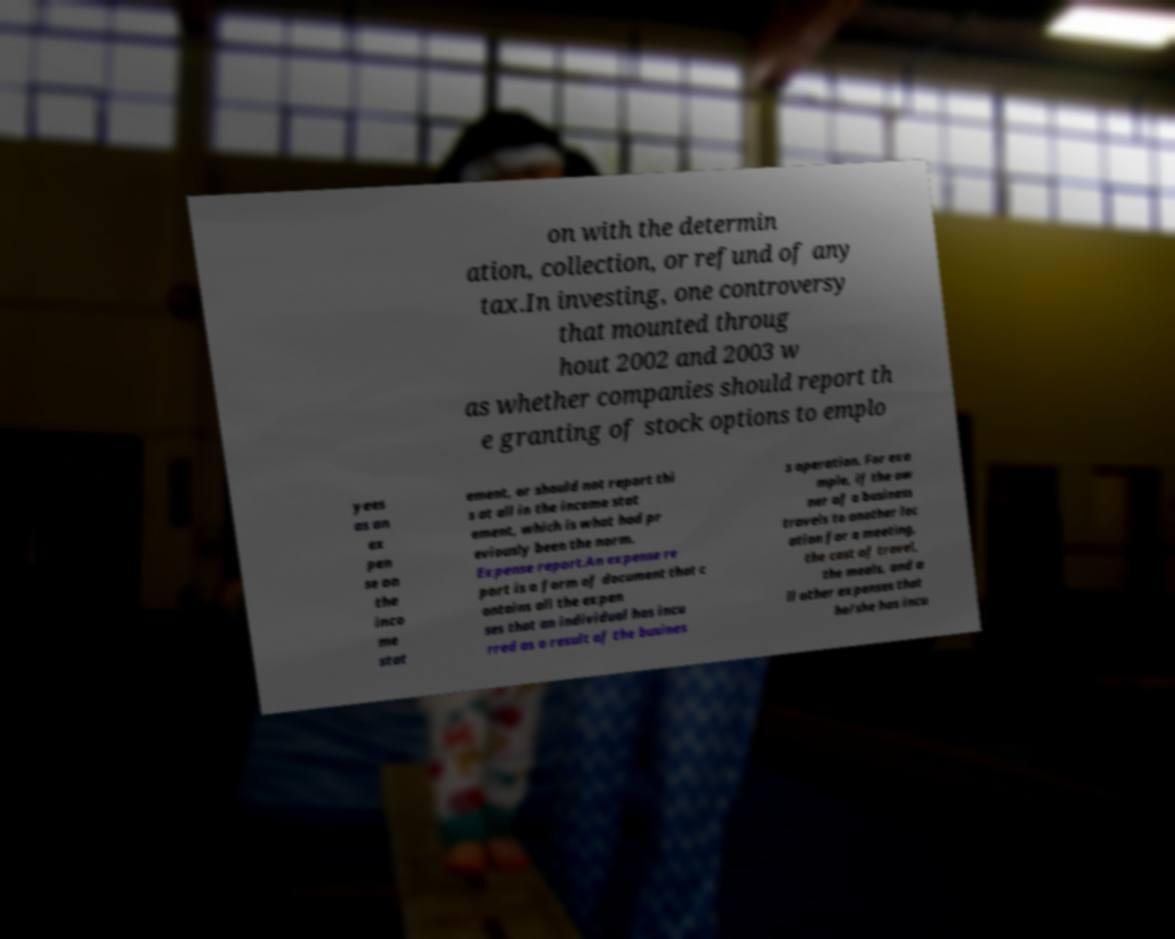Please identify and transcribe the text found in this image. on with the determin ation, collection, or refund of any tax.In investing, one controversy that mounted throug hout 2002 and 2003 w as whether companies should report th e granting of stock options to emplo yees as an ex pen se on the inco me stat ement, or should not report thi s at all in the income stat ement, which is what had pr eviously been the norm. Expense report.An expense re port is a form of document that c ontains all the expen ses that an individual has incu rred as a result of the busines s operation. For exa mple, if the ow ner of a business travels to another loc ation for a meeting, the cost of travel, the meals, and a ll other expenses that he/she has incu 